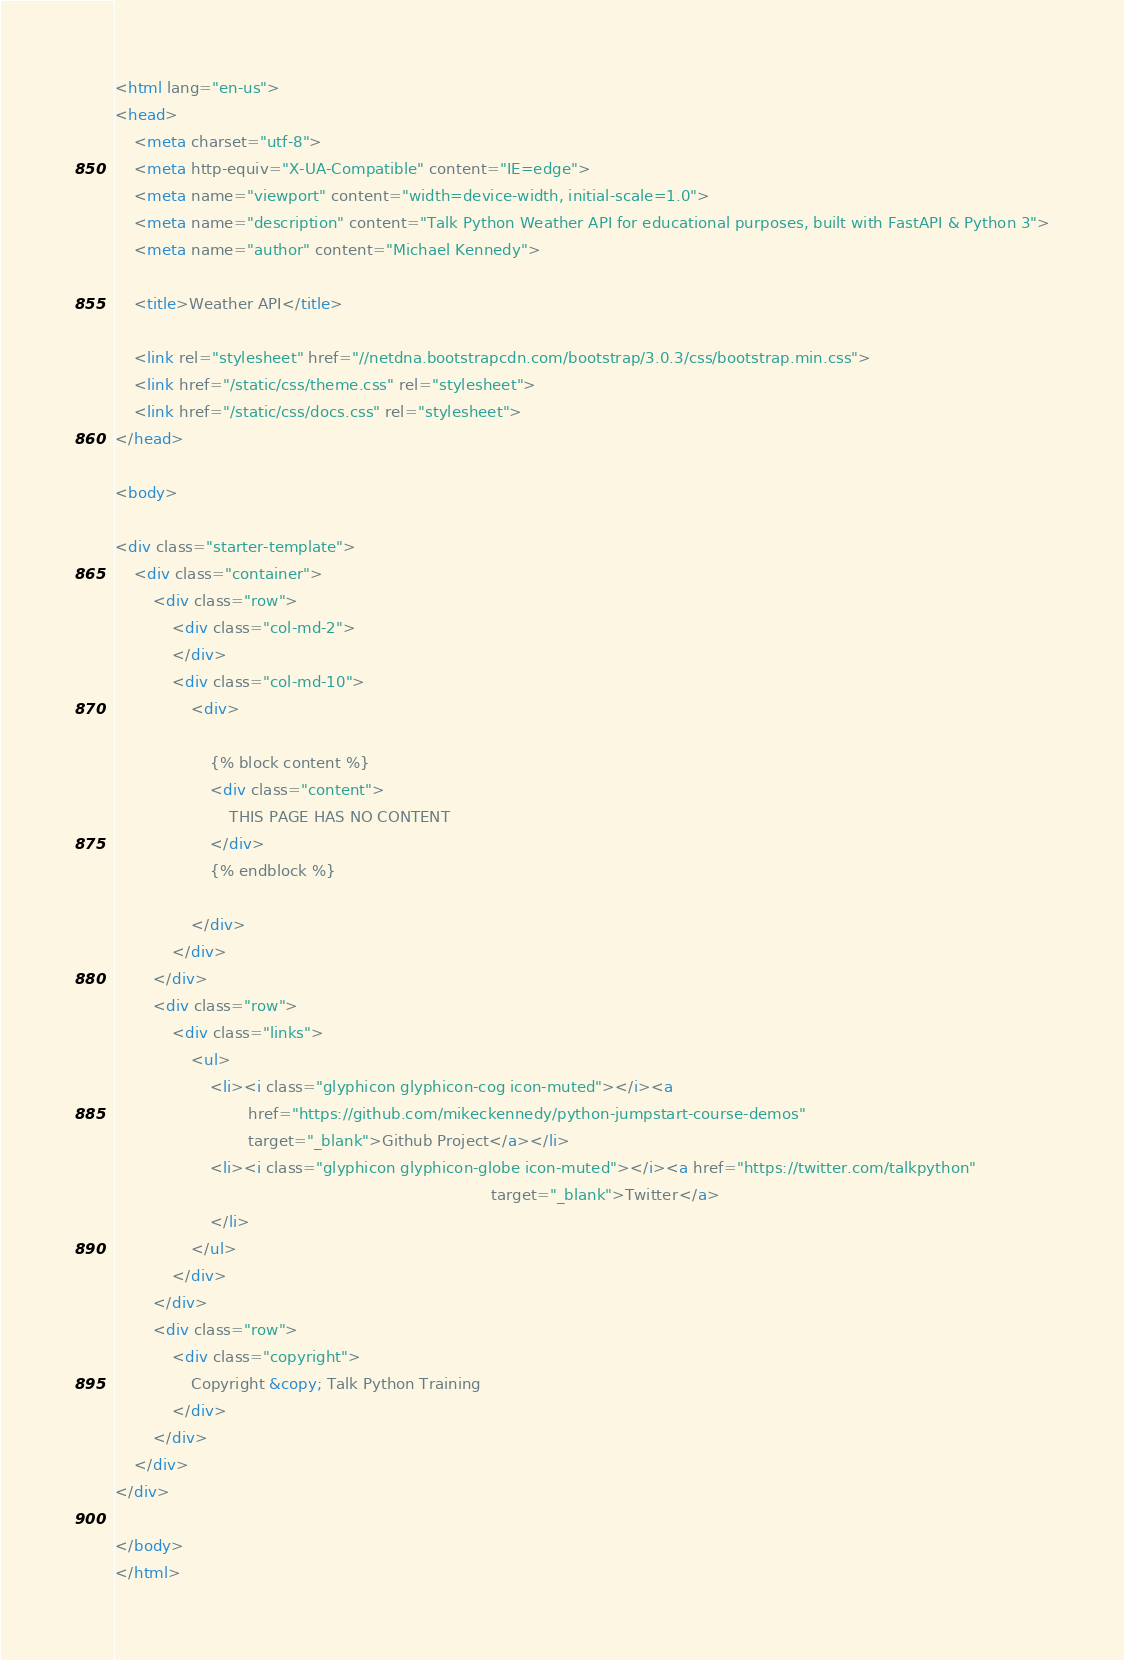Convert code to text. <code><loc_0><loc_0><loc_500><loc_500><_HTML_><html lang="en-us">
<head>
    <meta charset="utf-8">
    <meta http-equiv="X-UA-Compatible" content="IE=edge">
    <meta name="viewport" content="width=device-width, initial-scale=1.0">
    <meta name="description" content="Talk Python Weather API for educational purposes, built with FastAPI & Python 3">
    <meta name="author" content="Michael Kennedy">

    <title>Weather API</title>

    <link rel="stylesheet" href="//netdna.bootstrapcdn.com/bootstrap/3.0.3/css/bootstrap.min.css">
    <link href="/static/css/theme.css" rel="stylesheet">
    <link href="/static/css/docs.css" rel="stylesheet">
</head>

<body>

<div class="starter-template">
    <div class="container">
        <div class="row">
            <div class="col-md-2">
            </div>
            <div class="col-md-10">
                <div>

                    {% block content %}
                    <div class="content">
                        THIS PAGE HAS NO CONTENT
                    </div>
                    {% endblock %}

                </div>
            </div>
        </div>
        <div class="row">
            <div class="links">
                <ul>
                    <li><i class="glyphicon glyphicon-cog icon-muted"></i><a
                            href="https://github.com/mikeckennedy/python-jumpstart-course-demos"
                            target="_blank">Github Project</a></li>
                    <li><i class="glyphicon glyphicon-globe icon-muted"></i><a href="https://twitter.com/talkpython"
                                                                               target="_blank">Twitter</a>
                    </li>
                </ul>
            </div>
        </div>
        <div class="row">
            <div class="copyright">
                Copyright &copy; Talk Python Training
            </div>
        </div>
    </div>
</div>

</body>
</html></code> 